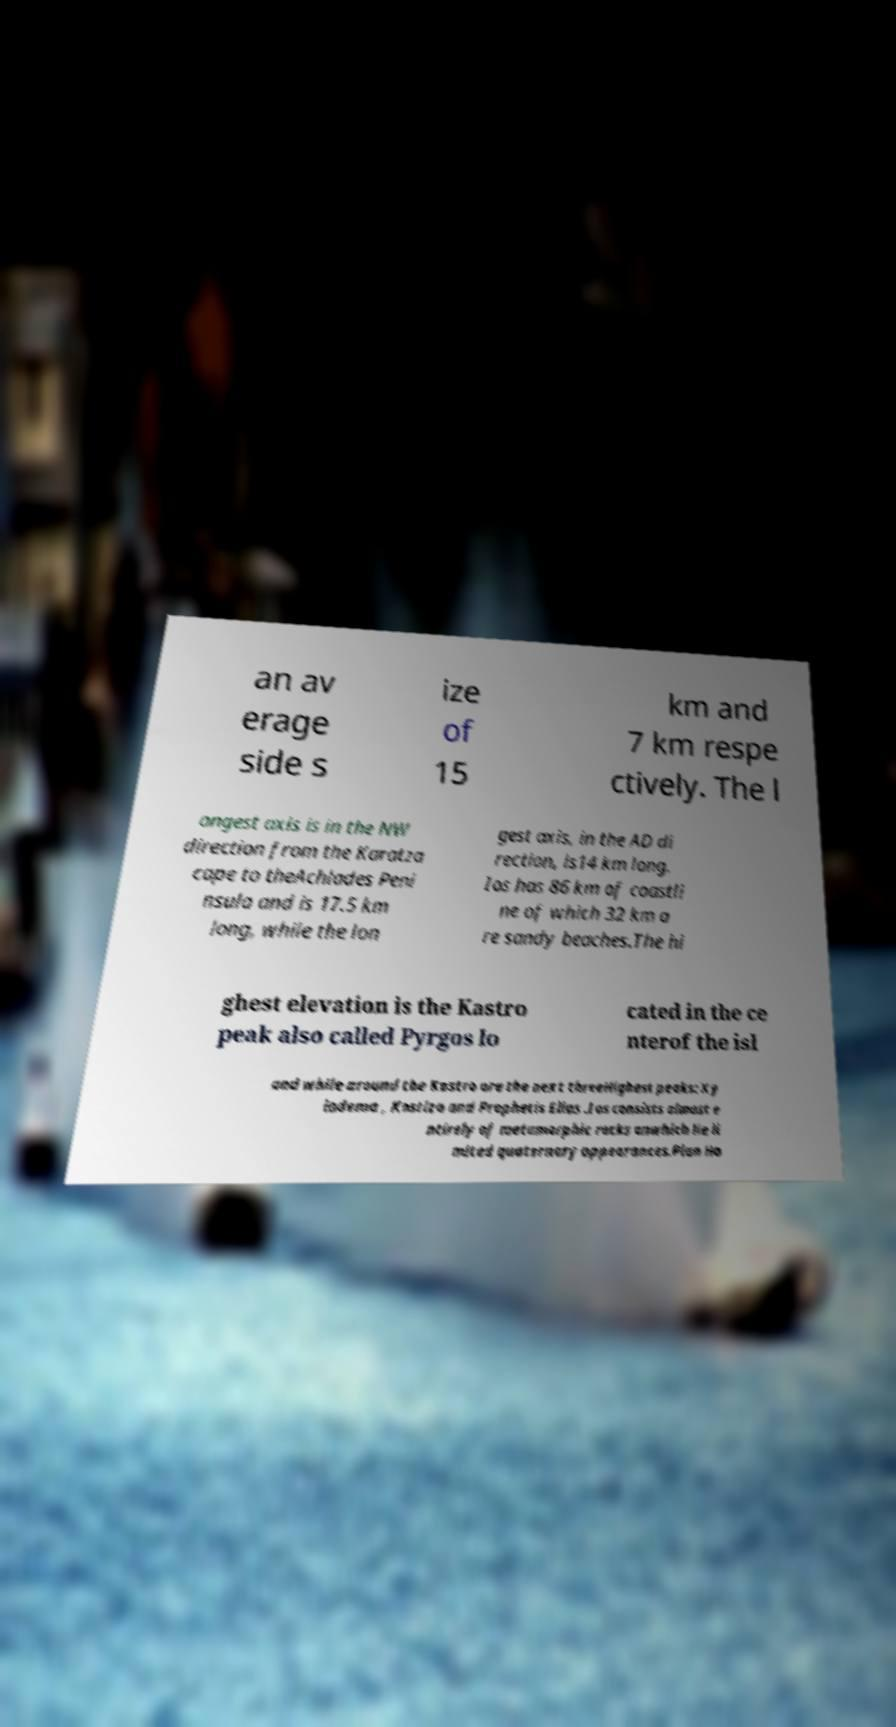Please read and relay the text visible in this image. What does it say? an av erage side s ize of 15 km and 7 km respe ctively. The l ongest axis is in the NW direction from the Karatza cape to theAchlades Peni nsula and is 17.5 km long, while the lon gest axis, in the AD di rection, is14 km long. Ios has 86 km of coastli ne of which 32 km a re sandy beaches.The hi ghest elevation is the Kastro peak also called Pyrgos lo cated in the ce nterof the isl and while around the Kastro are the next threeHighest peaks: Xy lodema , Kostiza and Prophetis Elias .Ios consists almost e ntirely of metamorphic rocks onwhich lie li mited quaternary appearances.Plan Ho 